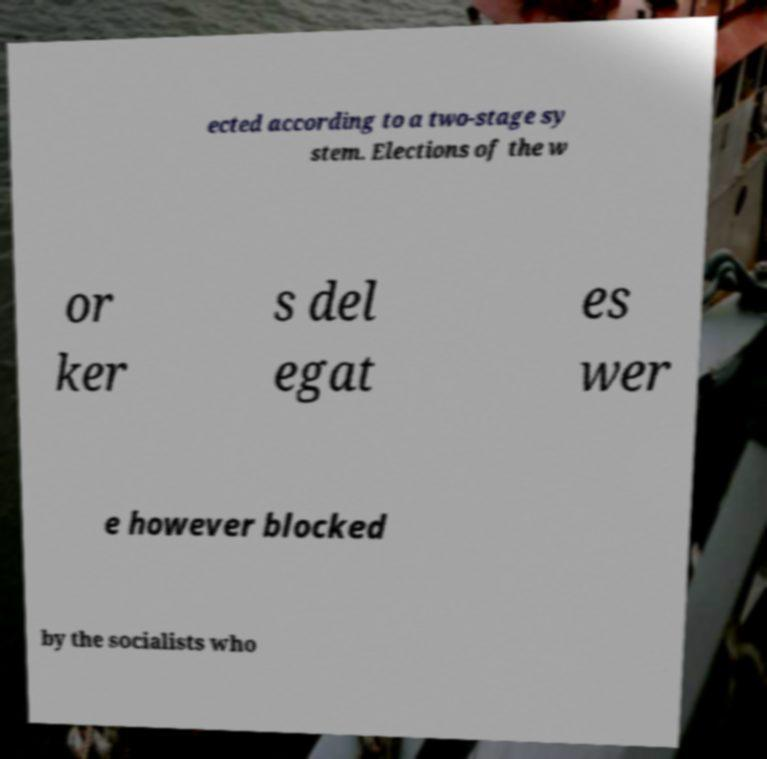For documentation purposes, I need the text within this image transcribed. Could you provide that? ected according to a two-stage sy stem. Elections of the w or ker s del egat es wer e however blocked by the socialists who 